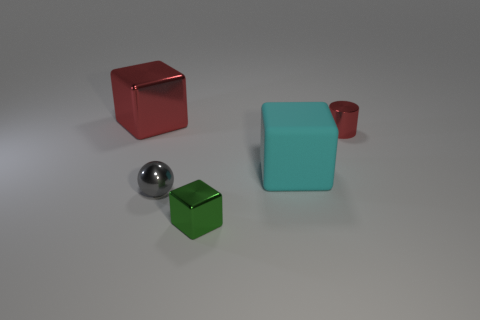What material is the cyan cube?
Your answer should be compact. Rubber. Do the tiny metal cylinder and the big metal block have the same color?
Provide a succinct answer. Yes. How many other things are the same material as the green block?
Offer a terse response. 3. What is the material of the thing that is right of the green metal object and on the left side of the small red object?
Provide a short and direct response. Rubber. What number of tiny objects are either cyan blocks or red blocks?
Your response must be concise. 0. The metal sphere is what size?
Keep it short and to the point. Small. What is the shape of the small red thing?
Offer a terse response. Cylinder. Is there anything else that has the same shape as the small gray object?
Offer a very short reply. No. Is the number of green metallic things on the right side of the red cube less than the number of metal things?
Make the answer very short. Yes. There is a metallic cylinder that is behind the tiny shiny block; is it the same color as the big metal object?
Offer a terse response. Yes. 